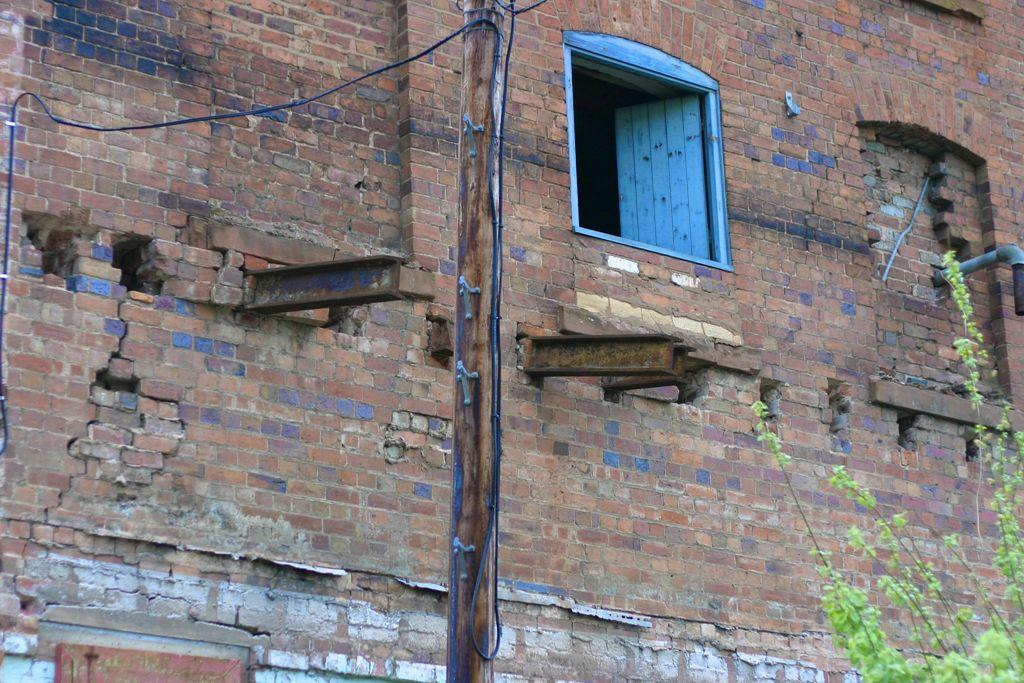What is the main object in the image? There is a wooden pole with a wire attached in the image. What is located near the wooden pole? There is a plant beside the wooden pole. What can be seen on the backside of the image? There is a wall with a window on the backside of the image. What letter is being spelled out by the wire in the image? There is no letter being spelled out by the wire in the image; it is simply a wire attached to a wooden pole. 